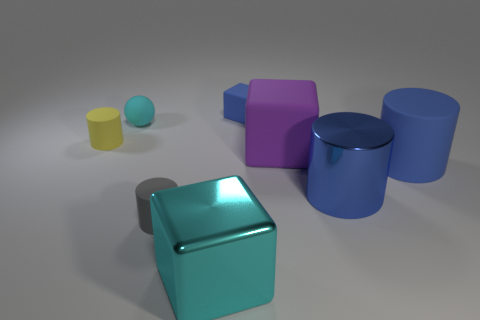How many things are cylinders on the right side of the cyan sphere or tiny cylinders that are behind the large purple matte thing?
Make the answer very short. 4. How many objects are either red metallic objects or small cylinders left of the cyan matte ball?
Your answer should be compact. 1. There is a cube in front of the big shiny thing behind the cyan thing that is in front of the small rubber ball; what size is it?
Your answer should be very brief. Large. There is another cube that is the same size as the shiny block; what material is it?
Your response must be concise. Rubber. Is there a brown metallic cylinder that has the same size as the purple block?
Keep it short and to the point. No. There is a thing that is behind the sphere; does it have the same size as the big matte cylinder?
Provide a short and direct response. No. What is the shape of the tiny rubber thing that is both behind the blue shiny cylinder and in front of the small cyan rubber sphere?
Ensure brevity in your answer.  Cylinder. Is the number of large blue rubber cylinders in front of the big rubber block greater than the number of cubes?
Offer a terse response. No. There is a blue cylinder that is made of the same material as the tiny block; what size is it?
Offer a terse response. Large. How many big objects have the same color as the big shiny cylinder?
Provide a succinct answer. 1. 